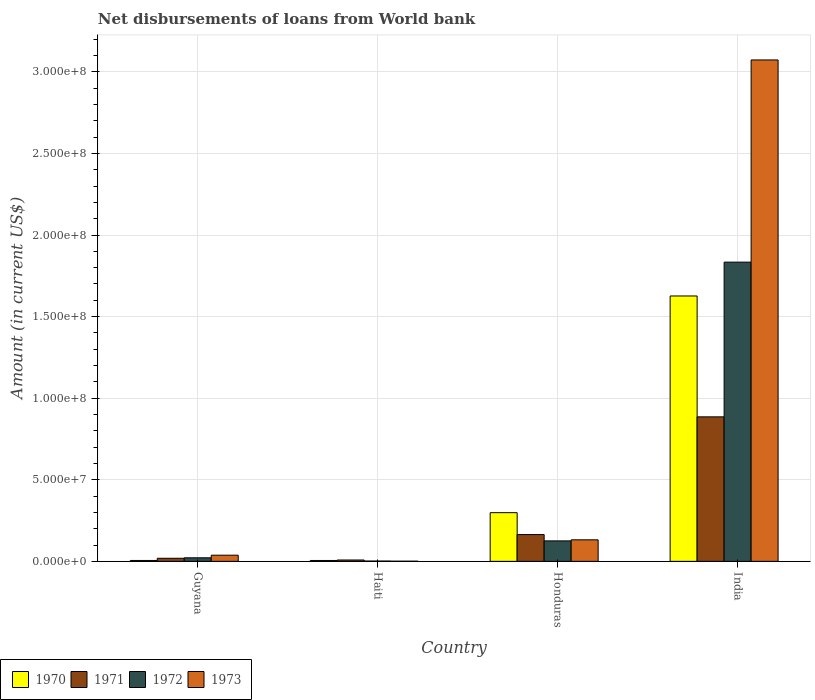How many groups of bars are there?
Give a very brief answer. 4. Are the number of bars per tick equal to the number of legend labels?
Offer a very short reply. Yes. Are the number of bars on each tick of the X-axis equal?
Your answer should be compact. Yes. How many bars are there on the 4th tick from the left?
Offer a terse response. 4. What is the label of the 2nd group of bars from the left?
Your response must be concise. Haiti. In how many cases, is the number of bars for a given country not equal to the number of legend labels?
Offer a terse response. 0. What is the amount of loan disbursed from World Bank in 1973 in Haiti?
Keep it short and to the point. 9.80e+04. Across all countries, what is the maximum amount of loan disbursed from World Bank in 1972?
Your answer should be very brief. 1.83e+08. Across all countries, what is the minimum amount of loan disbursed from World Bank in 1972?
Ensure brevity in your answer.  1.96e+05. In which country was the amount of loan disbursed from World Bank in 1973 minimum?
Keep it short and to the point. Haiti. What is the total amount of loan disbursed from World Bank in 1970 in the graph?
Your response must be concise. 1.94e+08. What is the difference between the amount of loan disbursed from World Bank in 1973 in Haiti and that in India?
Provide a succinct answer. -3.07e+08. What is the difference between the amount of loan disbursed from World Bank in 1971 in Honduras and the amount of loan disbursed from World Bank in 1970 in Guyana?
Offer a terse response. 1.59e+07. What is the average amount of loan disbursed from World Bank in 1970 per country?
Your answer should be very brief. 4.84e+07. What is the difference between the amount of loan disbursed from World Bank of/in 1971 and amount of loan disbursed from World Bank of/in 1970 in Honduras?
Provide a short and direct response. -1.34e+07. What is the ratio of the amount of loan disbursed from World Bank in 1971 in Haiti to that in India?
Offer a terse response. 0.01. What is the difference between the highest and the second highest amount of loan disbursed from World Bank in 1973?
Your answer should be compact. 3.04e+08. What is the difference between the highest and the lowest amount of loan disbursed from World Bank in 1970?
Offer a very short reply. 1.62e+08. Is it the case that in every country, the sum of the amount of loan disbursed from World Bank in 1972 and amount of loan disbursed from World Bank in 1973 is greater than the sum of amount of loan disbursed from World Bank in 1971 and amount of loan disbursed from World Bank in 1970?
Offer a very short reply. No. What does the 2nd bar from the left in Haiti represents?
Keep it short and to the point. 1971. What does the 2nd bar from the right in Haiti represents?
Ensure brevity in your answer.  1972. Are all the bars in the graph horizontal?
Keep it short and to the point. No. How many countries are there in the graph?
Provide a succinct answer. 4. Does the graph contain grids?
Provide a succinct answer. Yes. How many legend labels are there?
Provide a succinct answer. 4. What is the title of the graph?
Offer a terse response. Net disbursements of loans from World bank. Does "1981" appear as one of the legend labels in the graph?
Ensure brevity in your answer.  No. What is the label or title of the Y-axis?
Offer a very short reply. Amount (in current US$). What is the Amount (in current US$) in 1970 in Guyana?
Your answer should be compact. 5.53e+05. What is the Amount (in current US$) of 1971 in Guyana?
Provide a succinct answer. 1.89e+06. What is the Amount (in current US$) of 1972 in Guyana?
Your answer should be very brief. 2.18e+06. What is the Amount (in current US$) of 1973 in Guyana?
Your answer should be compact. 3.78e+06. What is the Amount (in current US$) of 1970 in Haiti?
Provide a short and direct response. 5.38e+05. What is the Amount (in current US$) of 1971 in Haiti?
Your answer should be very brief. 8.34e+05. What is the Amount (in current US$) in 1972 in Haiti?
Offer a very short reply. 1.96e+05. What is the Amount (in current US$) in 1973 in Haiti?
Keep it short and to the point. 9.80e+04. What is the Amount (in current US$) of 1970 in Honduras?
Give a very brief answer. 2.98e+07. What is the Amount (in current US$) in 1971 in Honduras?
Provide a short and direct response. 1.64e+07. What is the Amount (in current US$) in 1972 in Honduras?
Ensure brevity in your answer.  1.25e+07. What is the Amount (in current US$) of 1973 in Honduras?
Keep it short and to the point. 1.32e+07. What is the Amount (in current US$) in 1970 in India?
Make the answer very short. 1.63e+08. What is the Amount (in current US$) of 1971 in India?
Give a very brief answer. 8.86e+07. What is the Amount (in current US$) of 1972 in India?
Offer a very short reply. 1.83e+08. What is the Amount (in current US$) in 1973 in India?
Offer a very short reply. 3.07e+08. Across all countries, what is the maximum Amount (in current US$) of 1970?
Give a very brief answer. 1.63e+08. Across all countries, what is the maximum Amount (in current US$) in 1971?
Make the answer very short. 8.86e+07. Across all countries, what is the maximum Amount (in current US$) of 1972?
Offer a very short reply. 1.83e+08. Across all countries, what is the maximum Amount (in current US$) in 1973?
Make the answer very short. 3.07e+08. Across all countries, what is the minimum Amount (in current US$) in 1970?
Make the answer very short. 5.38e+05. Across all countries, what is the minimum Amount (in current US$) of 1971?
Provide a succinct answer. 8.34e+05. Across all countries, what is the minimum Amount (in current US$) in 1972?
Your answer should be compact. 1.96e+05. Across all countries, what is the minimum Amount (in current US$) in 1973?
Ensure brevity in your answer.  9.80e+04. What is the total Amount (in current US$) of 1970 in the graph?
Ensure brevity in your answer.  1.94e+08. What is the total Amount (in current US$) in 1971 in the graph?
Provide a short and direct response. 1.08e+08. What is the total Amount (in current US$) of 1972 in the graph?
Make the answer very short. 1.98e+08. What is the total Amount (in current US$) of 1973 in the graph?
Your answer should be very brief. 3.24e+08. What is the difference between the Amount (in current US$) of 1970 in Guyana and that in Haiti?
Your answer should be very brief. 1.50e+04. What is the difference between the Amount (in current US$) in 1971 in Guyana and that in Haiti?
Your response must be concise. 1.06e+06. What is the difference between the Amount (in current US$) in 1972 in Guyana and that in Haiti?
Ensure brevity in your answer.  1.98e+06. What is the difference between the Amount (in current US$) in 1973 in Guyana and that in Haiti?
Make the answer very short. 3.68e+06. What is the difference between the Amount (in current US$) of 1970 in Guyana and that in Honduras?
Your answer should be very brief. -2.93e+07. What is the difference between the Amount (in current US$) of 1971 in Guyana and that in Honduras?
Offer a very short reply. -1.45e+07. What is the difference between the Amount (in current US$) in 1972 in Guyana and that in Honduras?
Keep it short and to the point. -1.04e+07. What is the difference between the Amount (in current US$) in 1973 in Guyana and that in Honduras?
Your answer should be very brief. -9.42e+06. What is the difference between the Amount (in current US$) of 1970 in Guyana and that in India?
Provide a succinct answer. -1.62e+08. What is the difference between the Amount (in current US$) in 1971 in Guyana and that in India?
Your response must be concise. -8.67e+07. What is the difference between the Amount (in current US$) in 1972 in Guyana and that in India?
Offer a terse response. -1.81e+08. What is the difference between the Amount (in current US$) of 1973 in Guyana and that in India?
Keep it short and to the point. -3.04e+08. What is the difference between the Amount (in current US$) of 1970 in Haiti and that in Honduras?
Ensure brevity in your answer.  -2.93e+07. What is the difference between the Amount (in current US$) of 1971 in Haiti and that in Honduras?
Provide a short and direct response. -1.56e+07. What is the difference between the Amount (in current US$) in 1972 in Haiti and that in Honduras?
Keep it short and to the point. -1.23e+07. What is the difference between the Amount (in current US$) of 1973 in Haiti and that in Honduras?
Your response must be concise. -1.31e+07. What is the difference between the Amount (in current US$) in 1970 in Haiti and that in India?
Make the answer very short. -1.62e+08. What is the difference between the Amount (in current US$) of 1971 in Haiti and that in India?
Make the answer very short. -8.77e+07. What is the difference between the Amount (in current US$) of 1972 in Haiti and that in India?
Offer a terse response. -1.83e+08. What is the difference between the Amount (in current US$) of 1973 in Haiti and that in India?
Make the answer very short. -3.07e+08. What is the difference between the Amount (in current US$) in 1970 in Honduras and that in India?
Your answer should be compact. -1.33e+08. What is the difference between the Amount (in current US$) in 1971 in Honduras and that in India?
Provide a succinct answer. -7.21e+07. What is the difference between the Amount (in current US$) of 1972 in Honduras and that in India?
Your answer should be compact. -1.71e+08. What is the difference between the Amount (in current US$) of 1973 in Honduras and that in India?
Provide a short and direct response. -2.94e+08. What is the difference between the Amount (in current US$) of 1970 in Guyana and the Amount (in current US$) of 1971 in Haiti?
Provide a short and direct response. -2.81e+05. What is the difference between the Amount (in current US$) of 1970 in Guyana and the Amount (in current US$) of 1972 in Haiti?
Your response must be concise. 3.57e+05. What is the difference between the Amount (in current US$) in 1970 in Guyana and the Amount (in current US$) in 1973 in Haiti?
Keep it short and to the point. 4.55e+05. What is the difference between the Amount (in current US$) in 1971 in Guyana and the Amount (in current US$) in 1972 in Haiti?
Provide a short and direct response. 1.70e+06. What is the difference between the Amount (in current US$) in 1971 in Guyana and the Amount (in current US$) in 1973 in Haiti?
Ensure brevity in your answer.  1.80e+06. What is the difference between the Amount (in current US$) of 1972 in Guyana and the Amount (in current US$) of 1973 in Haiti?
Offer a terse response. 2.08e+06. What is the difference between the Amount (in current US$) of 1970 in Guyana and the Amount (in current US$) of 1971 in Honduras?
Keep it short and to the point. -1.59e+07. What is the difference between the Amount (in current US$) of 1970 in Guyana and the Amount (in current US$) of 1972 in Honduras?
Your answer should be very brief. -1.20e+07. What is the difference between the Amount (in current US$) of 1970 in Guyana and the Amount (in current US$) of 1973 in Honduras?
Your answer should be compact. -1.26e+07. What is the difference between the Amount (in current US$) in 1971 in Guyana and the Amount (in current US$) in 1972 in Honduras?
Give a very brief answer. -1.07e+07. What is the difference between the Amount (in current US$) in 1971 in Guyana and the Amount (in current US$) in 1973 in Honduras?
Give a very brief answer. -1.13e+07. What is the difference between the Amount (in current US$) in 1972 in Guyana and the Amount (in current US$) in 1973 in Honduras?
Keep it short and to the point. -1.10e+07. What is the difference between the Amount (in current US$) of 1970 in Guyana and the Amount (in current US$) of 1971 in India?
Provide a succinct answer. -8.80e+07. What is the difference between the Amount (in current US$) in 1970 in Guyana and the Amount (in current US$) in 1972 in India?
Offer a terse response. -1.83e+08. What is the difference between the Amount (in current US$) of 1970 in Guyana and the Amount (in current US$) of 1973 in India?
Ensure brevity in your answer.  -3.07e+08. What is the difference between the Amount (in current US$) of 1971 in Guyana and the Amount (in current US$) of 1972 in India?
Give a very brief answer. -1.81e+08. What is the difference between the Amount (in current US$) in 1971 in Guyana and the Amount (in current US$) in 1973 in India?
Offer a terse response. -3.05e+08. What is the difference between the Amount (in current US$) in 1972 in Guyana and the Amount (in current US$) in 1973 in India?
Your response must be concise. -3.05e+08. What is the difference between the Amount (in current US$) of 1970 in Haiti and the Amount (in current US$) of 1971 in Honduras?
Ensure brevity in your answer.  -1.59e+07. What is the difference between the Amount (in current US$) of 1970 in Haiti and the Amount (in current US$) of 1972 in Honduras?
Ensure brevity in your answer.  -1.20e+07. What is the difference between the Amount (in current US$) of 1970 in Haiti and the Amount (in current US$) of 1973 in Honduras?
Offer a very short reply. -1.27e+07. What is the difference between the Amount (in current US$) of 1971 in Haiti and the Amount (in current US$) of 1972 in Honduras?
Make the answer very short. -1.17e+07. What is the difference between the Amount (in current US$) in 1971 in Haiti and the Amount (in current US$) in 1973 in Honduras?
Your answer should be compact. -1.24e+07. What is the difference between the Amount (in current US$) of 1972 in Haiti and the Amount (in current US$) of 1973 in Honduras?
Offer a very short reply. -1.30e+07. What is the difference between the Amount (in current US$) of 1970 in Haiti and the Amount (in current US$) of 1971 in India?
Provide a short and direct response. -8.80e+07. What is the difference between the Amount (in current US$) of 1970 in Haiti and the Amount (in current US$) of 1972 in India?
Keep it short and to the point. -1.83e+08. What is the difference between the Amount (in current US$) of 1970 in Haiti and the Amount (in current US$) of 1973 in India?
Provide a succinct answer. -3.07e+08. What is the difference between the Amount (in current US$) of 1971 in Haiti and the Amount (in current US$) of 1972 in India?
Make the answer very short. -1.83e+08. What is the difference between the Amount (in current US$) in 1971 in Haiti and the Amount (in current US$) in 1973 in India?
Provide a short and direct response. -3.06e+08. What is the difference between the Amount (in current US$) of 1972 in Haiti and the Amount (in current US$) of 1973 in India?
Provide a succinct answer. -3.07e+08. What is the difference between the Amount (in current US$) in 1970 in Honduras and the Amount (in current US$) in 1971 in India?
Provide a short and direct response. -5.87e+07. What is the difference between the Amount (in current US$) of 1970 in Honduras and the Amount (in current US$) of 1972 in India?
Provide a short and direct response. -1.54e+08. What is the difference between the Amount (in current US$) of 1970 in Honduras and the Amount (in current US$) of 1973 in India?
Provide a succinct answer. -2.77e+08. What is the difference between the Amount (in current US$) of 1971 in Honduras and the Amount (in current US$) of 1972 in India?
Your response must be concise. -1.67e+08. What is the difference between the Amount (in current US$) of 1971 in Honduras and the Amount (in current US$) of 1973 in India?
Offer a very short reply. -2.91e+08. What is the difference between the Amount (in current US$) in 1972 in Honduras and the Amount (in current US$) in 1973 in India?
Keep it short and to the point. -2.95e+08. What is the average Amount (in current US$) of 1970 per country?
Keep it short and to the point. 4.84e+07. What is the average Amount (in current US$) in 1971 per country?
Give a very brief answer. 2.69e+07. What is the average Amount (in current US$) in 1972 per country?
Offer a terse response. 4.96e+07. What is the average Amount (in current US$) in 1973 per country?
Provide a short and direct response. 8.11e+07. What is the difference between the Amount (in current US$) in 1970 and Amount (in current US$) in 1971 in Guyana?
Make the answer very short. -1.34e+06. What is the difference between the Amount (in current US$) of 1970 and Amount (in current US$) of 1972 in Guyana?
Provide a short and direct response. -1.63e+06. What is the difference between the Amount (in current US$) of 1970 and Amount (in current US$) of 1973 in Guyana?
Your response must be concise. -3.23e+06. What is the difference between the Amount (in current US$) of 1971 and Amount (in current US$) of 1972 in Guyana?
Offer a very short reply. -2.87e+05. What is the difference between the Amount (in current US$) of 1971 and Amount (in current US$) of 1973 in Guyana?
Provide a succinct answer. -1.89e+06. What is the difference between the Amount (in current US$) in 1972 and Amount (in current US$) in 1973 in Guyana?
Give a very brief answer. -1.60e+06. What is the difference between the Amount (in current US$) in 1970 and Amount (in current US$) in 1971 in Haiti?
Make the answer very short. -2.96e+05. What is the difference between the Amount (in current US$) of 1970 and Amount (in current US$) of 1972 in Haiti?
Offer a very short reply. 3.42e+05. What is the difference between the Amount (in current US$) of 1971 and Amount (in current US$) of 1972 in Haiti?
Offer a terse response. 6.38e+05. What is the difference between the Amount (in current US$) in 1971 and Amount (in current US$) in 1973 in Haiti?
Keep it short and to the point. 7.36e+05. What is the difference between the Amount (in current US$) in 1972 and Amount (in current US$) in 1973 in Haiti?
Offer a very short reply. 9.80e+04. What is the difference between the Amount (in current US$) of 1970 and Amount (in current US$) of 1971 in Honduras?
Keep it short and to the point. 1.34e+07. What is the difference between the Amount (in current US$) in 1970 and Amount (in current US$) in 1972 in Honduras?
Give a very brief answer. 1.73e+07. What is the difference between the Amount (in current US$) in 1970 and Amount (in current US$) in 1973 in Honduras?
Your response must be concise. 1.66e+07. What is the difference between the Amount (in current US$) in 1971 and Amount (in current US$) in 1972 in Honduras?
Give a very brief answer. 3.88e+06. What is the difference between the Amount (in current US$) in 1971 and Amount (in current US$) in 1973 in Honduras?
Give a very brief answer. 3.23e+06. What is the difference between the Amount (in current US$) of 1972 and Amount (in current US$) of 1973 in Honduras?
Ensure brevity in your answer.  -6.51e+05. What is the difference between the Amount (in current US$) of 1970 and Amount (in current US$) of 1971 in India?
Offer a very short reply. 7.41e+07. What is the difference between the Amount (in current US$) in 1970 and Amount (in current US$) in 1972 in India?
Keep it short and to the point. -2.07e+07. What is the difference between the Amount (in current US$) in 1970 and Amount (in current US$) in 1973 in India?
Give a very brief answer. -1.45e+08. What is the difference between the Amount (in current US$) of 1971 and Amount (in current US$) of 1972 in India?
Your response must be concise. -9.48e+07. What is the difference between the Amount (in current US$) of 1971 and Amount (in current US$) of 1973 in India?
Provide a succinct answer. -2.19e+08. What is the difference between the Amount (in current US$) of 1972 and Amount (in current US$) of 1973 in India?
Offer a terse response. -1.24e+08. What is the ratio of the Amount (in current US$) of 1970 in Guyana to that in Haiti?
Offer a terse response. 1.03. What is the ratio of the Amount (in current US$) in 1971 in Guyana to that in Haiti?
Give a very brief answer. 2.27. What is the ratio of the Amount (in current US$) of 1972 in Guyana to that in Haiti?
Offer a terse response. 11.12. What is the ratio of the Amount (in current US$) of 1973 in Guyana to that in Haiti?
Your answer should be compact. 38.56. What is the ratio of the Amount (in current US$) of 1970 in Guyana to that in Honduras?
Give a very brief answer. 0.02. What is the ratio of the Amount (in current US$) in 1971 in Guyana to that in Honduras?
Give a very brief answer. 0.12. What is the ratio of the Amount (in current US$) in 1972 in Guyana to that in Honduras?
Offer a terse response. 0.17. What is the ratio of the Amount (in current US$) in 1973 in Guyana to that in Honduras?
Offer a terse response. 0.29. What is the ratio of the Amount (in current US$) of 1970 in Guyana to that in India?
Offer a very short reply. 0. What is the ratio of the Amount (in current US$) of 1971 in Guyana to that in India?
Your response must be concise. 0.02. What is the ratio of the Amount (in current US$) in 1972 in Guyana to that in India?
Offer a terse response. 0.01. What is the ratio of the Amount (in current US$) of 1973 in Guyana to that in India?
Ensure brevity in your answer.  0.01. What is the ratio of the Amount (in current US$) in 1970 in Haiti to that in Honduras?
Ensure brevity in your answer.  0.02. What is the ratio of the Amount (in current US$) of 1971 in Haiti to that in Honduras?
Offer a very short reply. 0.05. What is the ratio of the Amount (in current US$) in 1972 in Haiti to that in Honduras?
Provide a short and direct response. 0.02. What is the ratio of the Amount (in current US$) of 1973 in Haiti to that in Honduras?
Your answer should be very brief. 0.01. What is the ratio of the Amount (in current US$) in 1970 in Haiti to that in India?
Your response must be concise. 0. What is the ratio of the Amount (in current US$) of 1971 in Haiti to that in India?
Offer a very short reply. 0.01. What is the ratio of the Amount (in current US$) in 1972 in Haiti to that in India?
Ensure brevity in your answer.  0. What is the ratio of the Amount (in current US$) in 1970 in Honduras to that in India?
Make the answer very short. 0.18. What is the ratio of the Amount (in current US$) in 1971 in Honduras to that in India?
Provide a short and direct response. 0.19. What is the ratio of the Amount (in current US$) of 1972 in Honduras to that in India?
Keep it short and to the point. 0.07. What is the ratio of the Amount (in current US$) of 1973 in Honduras to that in India?
Keep it short and to the point. 0.04. What is the difference between the highest and the second highest Amount (in current US$) of 1970?
Provide a short and direct response. 1.33e+08. What is the difference between the highest and the second highest Amount (in current US$) in 1971?
Give a very brief answer. 7.21e+07. What is the difference between the highest and the second highest Amount (in current US$) in 1972?
Your response must be concise. 1.71e+08. What is the difference between the highest and the second highest Amount (in current US$) of 1973?
Offer a very short reply. 2.94e+08. What is the difference between the highest and the lowest Amount (in current US$) in 1970?
Provide a succinct answer. 1.62e+08. What is the difference between the highest and the lowest Amount (in current US$) in 1971?
Offer a terse response. 8.77e+07. What is the difference between the highest and the lowest Amount (in current US$) in 1972?
Your answer should be very brief. 1.83e+08. What is the difference between the highest and the lowest Amount (in current US$) of 1973?
Your answer should be very brief. 3.07e+08. 